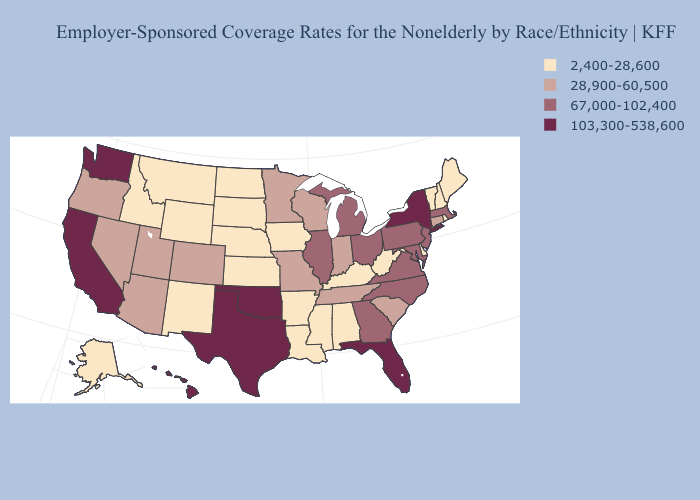Is the legend a continuous bar?
Be succinct. No. Name the states that have a value in the range 67,000-102,400?
Write a very short answer. Georgia, Illinois, Maryland, Massachusetts, Michigan, New Jersey, North Carolina, Ohio, Pennsylvania, Virginia. What is the lowest value in states that border Indiana?
Be succinct. 2,400-28,600. Does Missouri have the same value as Indiana?
Short answer required. Yes. Name the states that have a value in the range 103,300-538,600?
Quick response, please. California, Florida, Hawaii, New York, Oklahoma, Texas, Washington. What is the value of New York?
Give a very brief answer. 103,300-538,600. What is the lowest value in the MidWest?
Keep it brief. 2,400-28,600. Name the states that have a value in the range 67,000-102,400?
Quick response, please. Georgia, Illinois, Maryland, Massachusetts, Michigan, New Jersey, North Carolina, Ohio, Pennsylvania, Virginia. Which states have the lowest value in the South?
Quick response, please. Alabama, Arkansas, Delaware, Kentucky, Louisiana, Mississippi, West Virginia. Which states have the lowest value in the West?
Keep it brief. Alaska, Idaho, Montana, New Mexico, Wyoming. What is the value of North Dakota?
Be succinct. 2,400-28,600. Name the states that have a value in the range 28,900-60,500?
Answer briefly. Arizona, Colorado, Connecticut, Indiana, Minnesota, Missouri, Nevada, Oregon, South Carolina, Tennessee, Utah, Wisconsin. Name the states that have a value in the range 103,300-538,600?
Concise answer only. California, Florida, Hawaii, New York, Oklahoma, Texas, Washington. Among the states that border Washington , does Oregon have the highest value?
Give a very brief answer. Yes. 